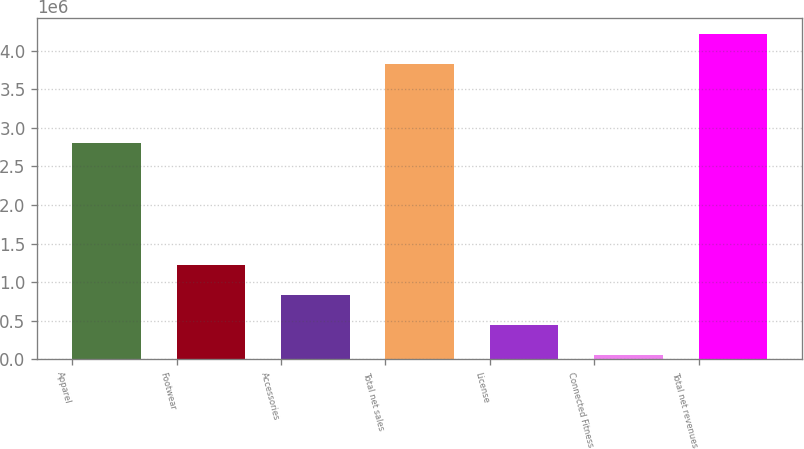<chart> <loc_0><loc_0><loc_500><loc_500><bar_chart><fcel>Apparel<fcel>Footwear<fcel>Accessories<fcel>Total net sales<fcel>License<fcel>Connected Fitness<fcel>Total net revenues<nl><fcel>2.80106e+06<fcel>1.22638e+06<fcel>835395<fcel>3.82569e+06<fcel>444405<fcel>53415<fcel>4.21668e+06<nl></chart> 